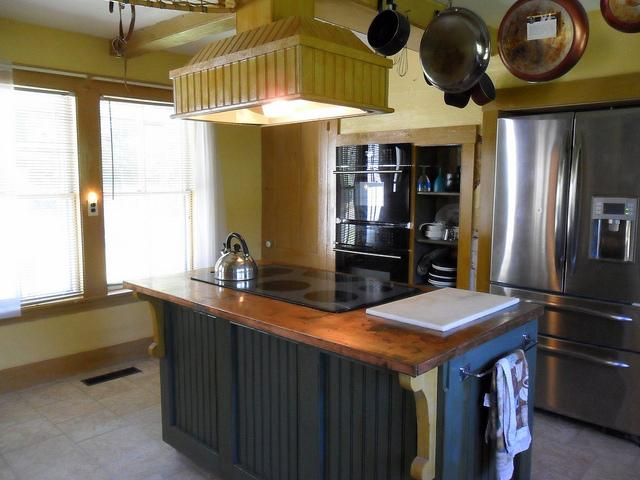What is the white rectangle on the island for? Please explain your reasoning. cutting. A large, flat object is on a counter next to a stove in a kitchen. 